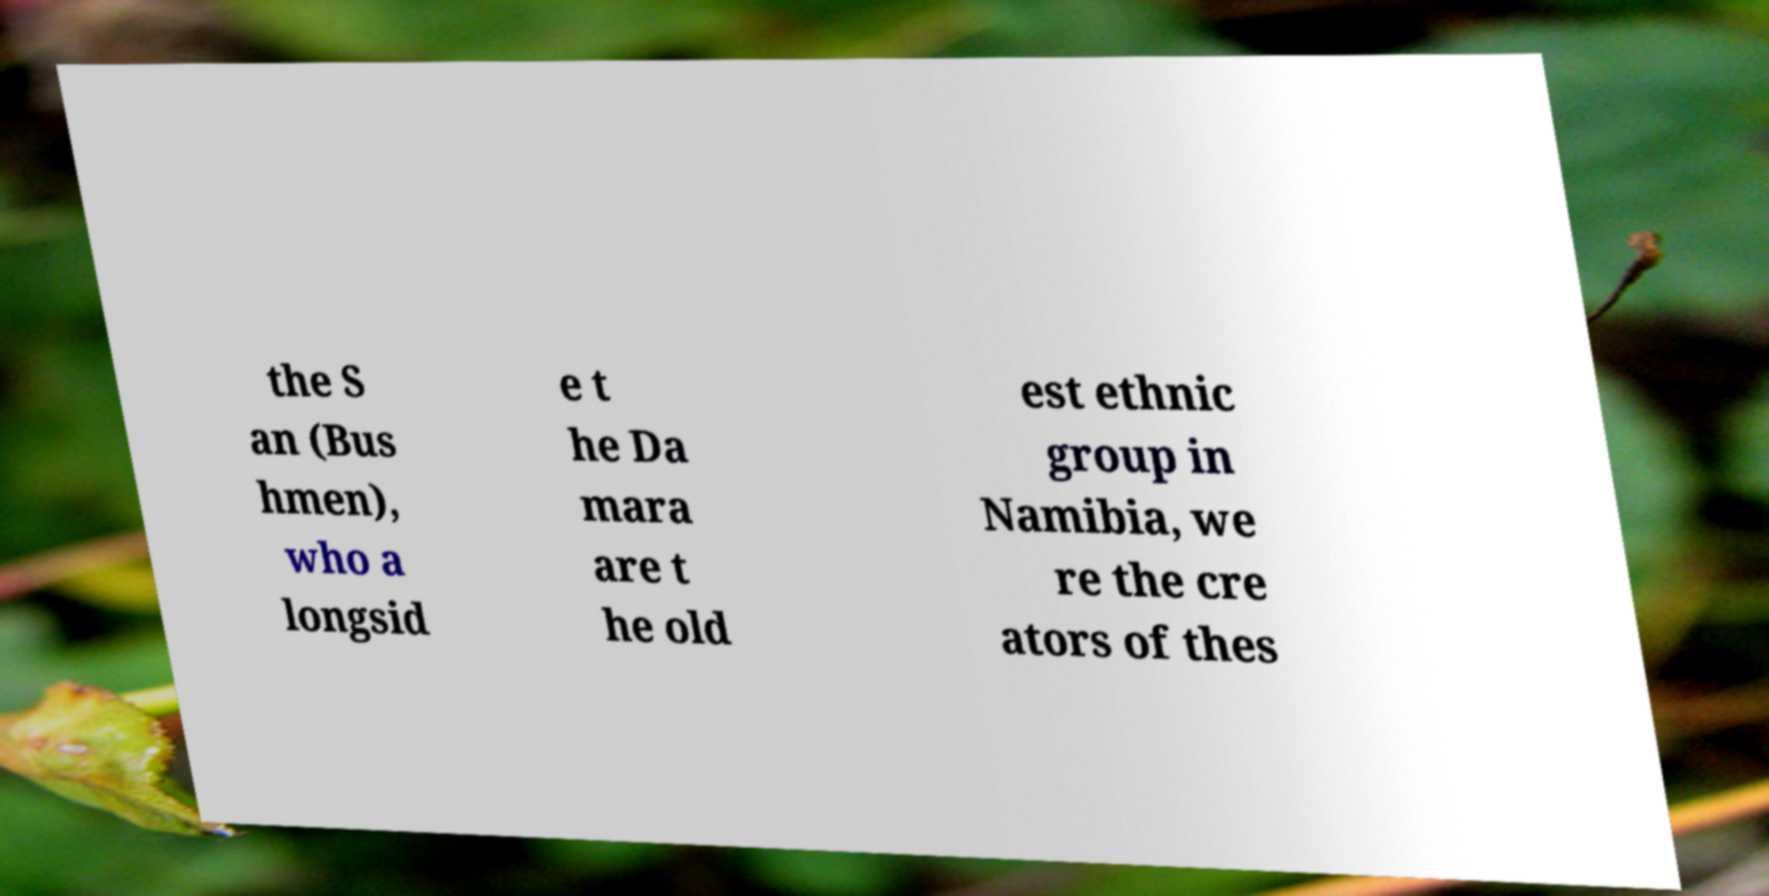I need the written content from this picture converted into text. Can you do that? the S an (Bus hmen), who a longsid e t he Da mara are t he old est ethnic group in Namibia, we re the cre ators of thes 